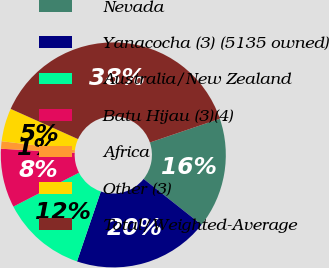<chart> <loc_0><loc_0><loc_500><loc_500><pie_chart><fcel>Nevada<fcel>Yanacocha (3) (5135 owned)<fcel>Australia/New Zealand<fcel>Batu Hijau (3)(4)<fcel>Africa<fcel>Other (3)<fcel>Total/Weighted-Average<nl><fcel>15.87%<fcel>19.57%<fcel>12.17%<fcel>8.47%<fcel>1.07%<fcel>4.77%<fcel>38.07%<nl></chart> 